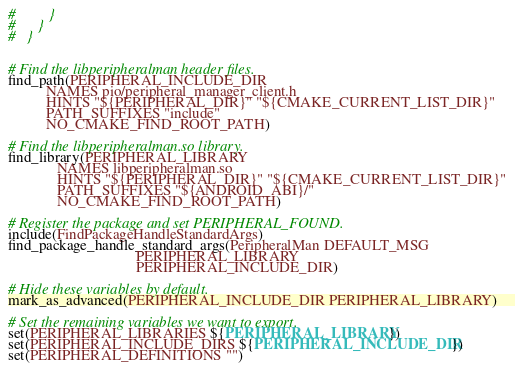<code> <loc_0><loc_0><loc_500><loc_500><_CMake_>#         }
#      }
#   }


# Find the libperipheralman header files.
find_path(PERIPHERAL_INCLUDE_DIR
          NAMES pio/peripheral_manager_client.h
          HINTS "${PERIPHERAL_DIR}" "${CMAKE_CURRENT_LIST_DIR}"
          PATH_SUFFIXES "include"
          NO_CMAKE_FIND_ROOT_PATH)

# Find the libperipheralman.so library.
find_library(PERIPHERAL_LIBRARY
             NAMES libperipheralman.so
             HINTS "${PERIPHERAL_DIR}" "${CMAKE_CURRENT_LIST_DIR}"
             PATH_SUFFIXES "${ANDROID_ABI}/"
             NO_CMAKE_FIND_ROOT_PATH)

# Register the package and set PERIPHERAL_FOUND.
include(FindPackageHandleStandardArgs)
find_package_handle_standard_args(PeripheralMan DEFAULT_MSG
                                  PERIPHERAL_LIBRARY
                                  PERIPHERAL_INCLUDE_DIR)

# Hide these variables by default.
mark_as_advanced(PERIPHERAL_INCLUDE_DIR PERIPHERAL_LIBRARY)

# Set the remaining variables we want to export.
set(PERIPHERAL_LIBRARIES ${PERIPHERAL_LIBRARY})
set(PERIPHERAL_INCLUDE_DIRS ${PERIPHERAL_INCLUDE_DIR})
set(PERIPHERAL_DEFINITIONS "")

</code> 